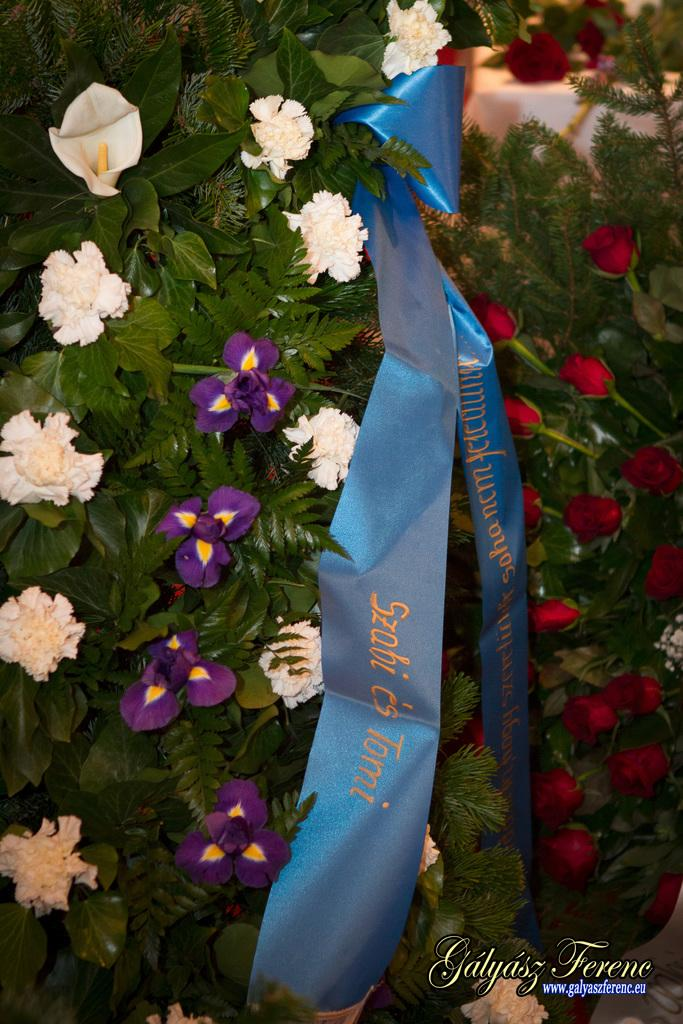What type of living organisms can be seen in the image? Plants can be seen in the image. What specific feature of the plants is noteworthy? The plants have many flowers. Can you describe the object in the image? There is an object in the image, but its description is not provided in the facts. What is written or depicted at the bottom of the image? There is some text at the bottom of the image. How many cats are sitting on the picture in the image? There are no cats or pictures present in the image. What type of cart is visible in the image? There is no cart visible in the image. 